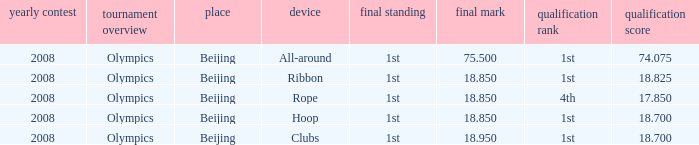On which apparatus did Kanayeva have a final score smaller than 75.5 and a qualifying score smaller than 18.7? Rope. 